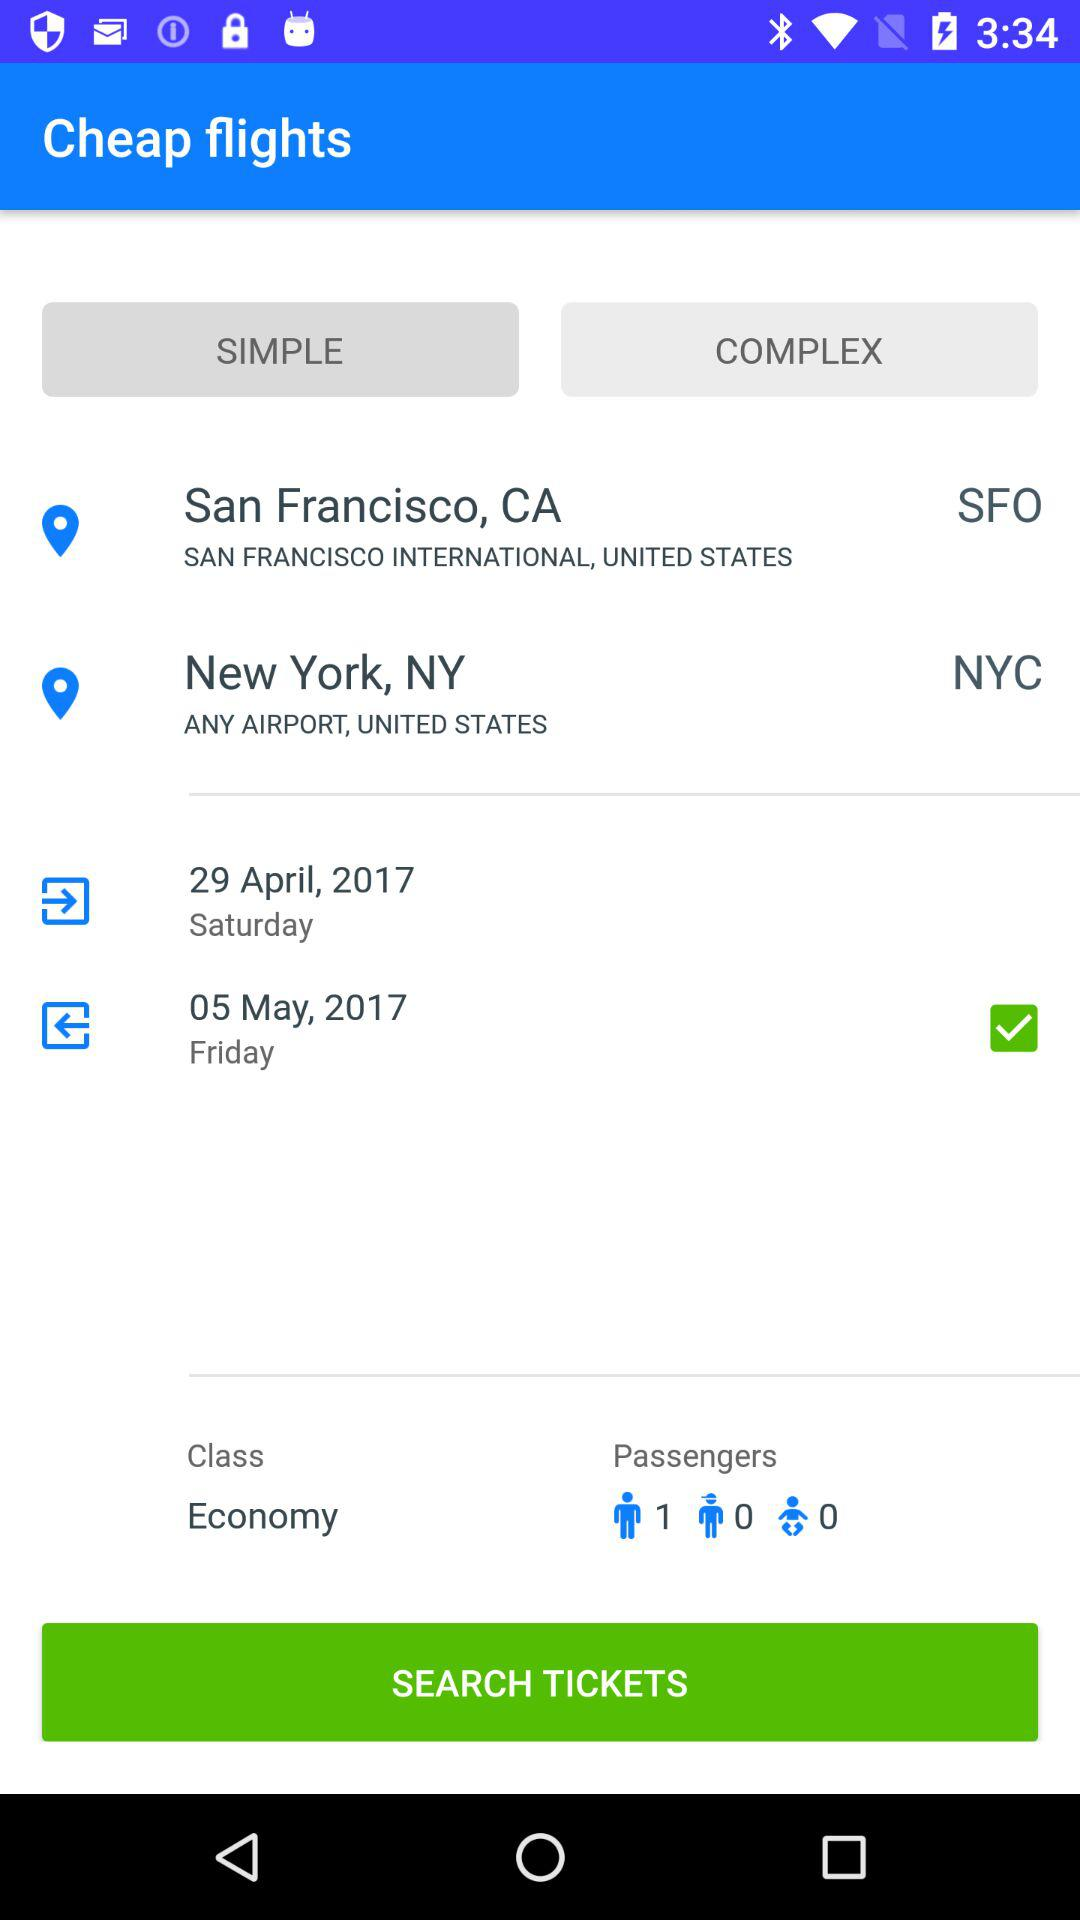How many passengers are selected?
Answer the question using a single word or phrase. 1 